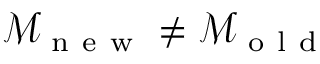<formula> <loc_0><loc_0><loc_500><loc_500>\mathcal { M } _ { n e w } \neq \mathcal { M } _ { o l d }</formula> 